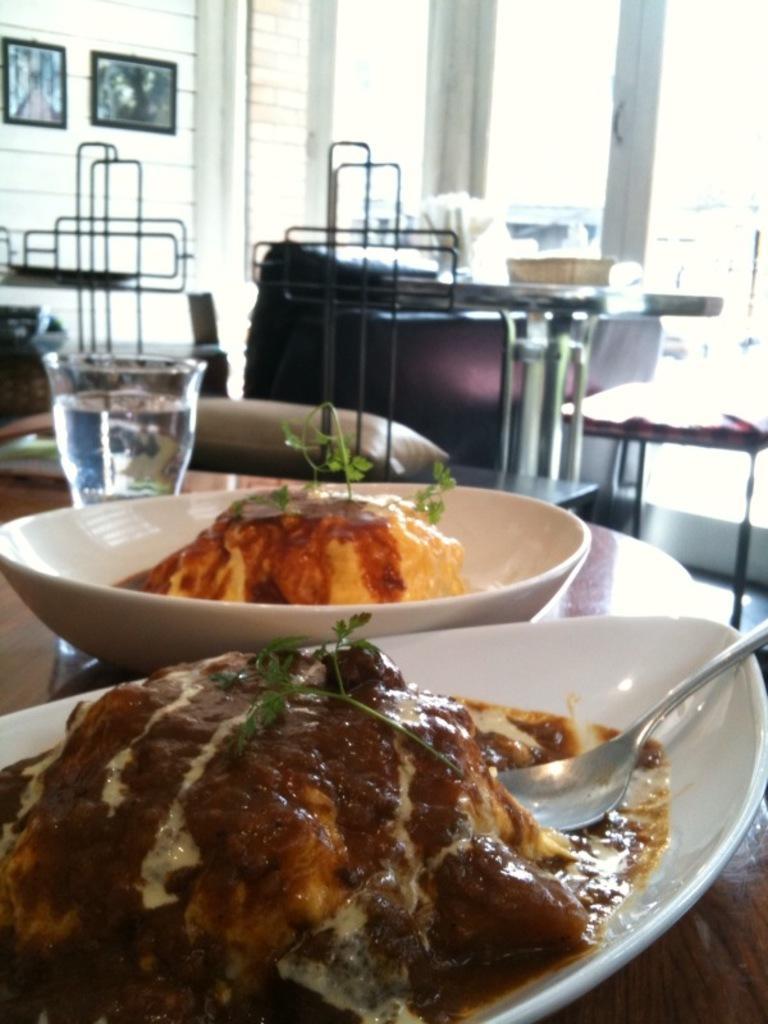Describe this image in one or two sentences. In this image there are food items in the bowls with a spoon and a glass of water on the table, and in the background there are chairs, tables, frames attached to the wall. 